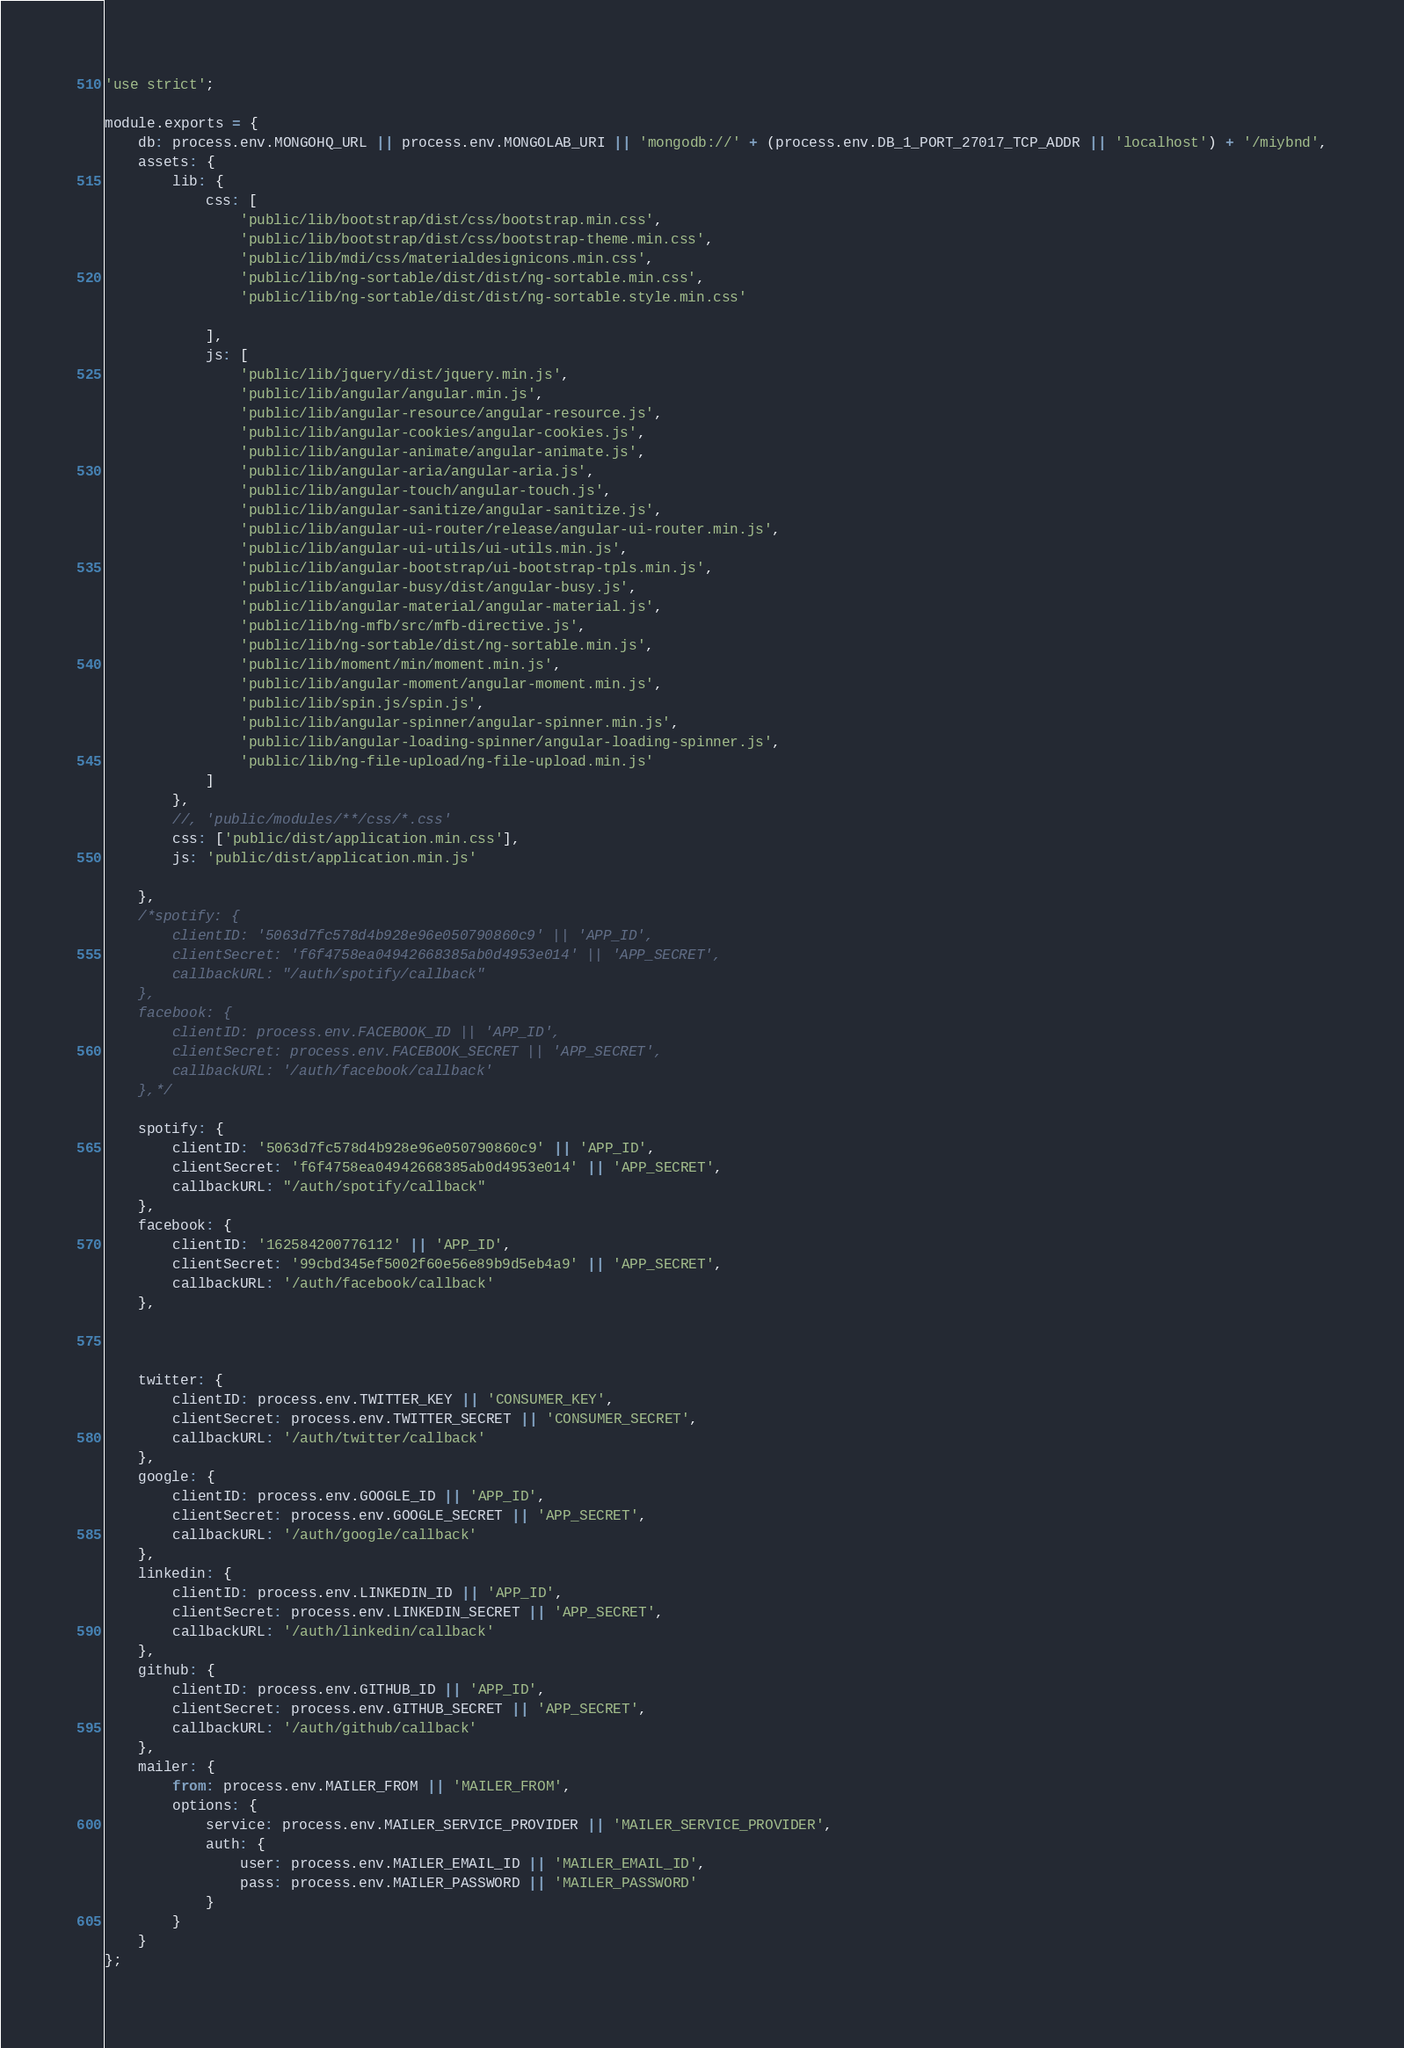Convert code to text. <code><loc_0><loc_0><loc_500><loc_500><_JavaScript_>'use strict';

module.exports = {
	db: process.env.MONGOHQ_URL || process.env.MONGOLAB_URI || 'mongodb://' + (process.env.DB_1_PORT_27017_TCP_ADDR || 'localhost') + '/miybnd',
	assets: {
		lib: {
			css: [
				'public/lib/bootstrap/dist/css/bootstrap.min.css',
				'public/lib/bootstrap/dist/css/bootstrap-theme.min.css',
				'public/lib/mdi/css/materialdesignicons.min.css',
				'public/lib/ng-sortable/dist/dist/ng-sortable.min.css',
				'public/lib/ng-sortable/dist/dist/ng-sortable.style.min.css'
		
			],
			js: [
				'public/lib/jquery/dist/jquery.min.js', 
				'public/lib/angular/angular.min.js',
				'public/lib/angular-resource/angular-resource.js', 
				'public/lib/angular-cookies/angular-cookies.js', 
				'public/lib/angular-animate/angular-animate.js', 
				'public/lib/angular-aria/angular-aria.js',
				'public/lib/angular-touch/angular-touch.js', 
				'public/lib/angular-sanitize/angular-sanitize.js', 
				'public/lib/angular-ui-router/release/angular-ui-router.min.js',
				'public/lib/angular-ui-utils/ui-utils.min.js',
				'public/lib/angular-bootstrap/ui-bootstrap-tpls.min.js',			
				'public/lib/angular-busy/dist/angular-busy.js',
			    'public/lib/angular-material/angular-material.js',
				'public/lib/ng-mfb/src/mfb-directive.js',
				'public/lib/ng-sortable/dist/ng-sortable.min.js',
				'public/lib/moment/min/moment.min.js',
				'public/lib/angular-moment/angular-moment.min.js',
				'public/lib/spin.js/spin.js',
				'public/lib/angular-spinner/angular-spinner.min.js',
				'public/lib/angular-loading-spinner/angular-loading-spinner.js',
				'public/lib/ng-file-upload/ng-file-upload.min.js'
			]
		},
		//, 'public/modules/**/css/*.css'
		css: ['public/dist/application.min.css'],
		js: 'public/dist/application.min.js'

	},
	/*spotify: {
        clientID: '5063d7fc578d4b928e96e050790860c9' || 'APP_ID',
        clientSecret: 'f6f4758ea04942668385ab0d4953e014' || 'APP_SECRET',
        callbackURL: "/auth/spotify/callback"
    },
	facebook: {
		clientID: process.env.FACEBOOK_ID || 'APP_ID',
		clientSecret: process.env.FACEBOOK_SECRET || 'APP_SECRET',
		callbackURL: '/auth/facebook/callback'
	},*/
    
    spotify: {
        clientID: '5063d7fc578d4b928e96e050790860c9' || 'APP_ID',
        clientSecret: 'f6f4758ea04942668385ab0d4953e014' || 'APP_SECRET',
        callbackURL: "/auth/spotify/callback"
    },
	facebook: {
		clientID: '162584200776112' || 'APP_ID',
		clientSecret: '99cbd345ef5002f60e56e89b9d5eb4a9' || 'APP_SECRET',
		callbackURL: '/auth/facebook/callback'
	},
    
    
    
	twitter: {
		clientID: process.env.TWITTER_KEY || 'CONSUMER_KEY',
		clientSecret: process.env.TWITTER_SECRET || 'CONSUMER_SECRET',
		callbackURL: '/auth/twitter/callback'
	},
	google: {
		clientID: process.env.GOOGLE_ID || 'APP_ID',
		clientSecret: process.env.GOOGLE_SECRET || 'APP_SECRET',
		callbackURL: '/auth/google/callback'
	},
	linkedin: {
		clientID: process.env.LINKEDIN_ID || 'APP_ID',
		clientSecret: process.env.LINKEDIN_SECRET || 'APP_SECRET',
		callbackURL: '/auth/linkedin/callback'
	},
	github: {
		clientID: process.env.GITHUB_ID || 'APP_ID',
		clientSecret: process.env.GITHUB_SECRET || 'APP_SECRET',
		callbackURL: '/auth/github/callback'
	},
	mailer: {
		from: process.env.MAILER_FROM || 'MAILER_FROM',
		options: {
			service: process.env.MAILER_SERVICE_PROVIDER || 'MAILER_SERVICE_PROVIDER',
			auth: {
				user: process.env.MAILER_EMAIL_ID || 'MAILER_EMAIL_ID',
				pass: process.env.MAILER_PASSWORD || 'MAILER_PASSWORD'
			}
		}
	}
};
</code> 